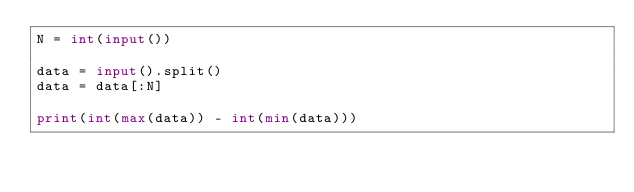Convert code to text. <code><loc_0><loc_0><loc_500><loc_500><_Python_>N = int(input())

data = input().split()
data = data[:N]

print(int(max(data)) - int(min(data)))

</code> 